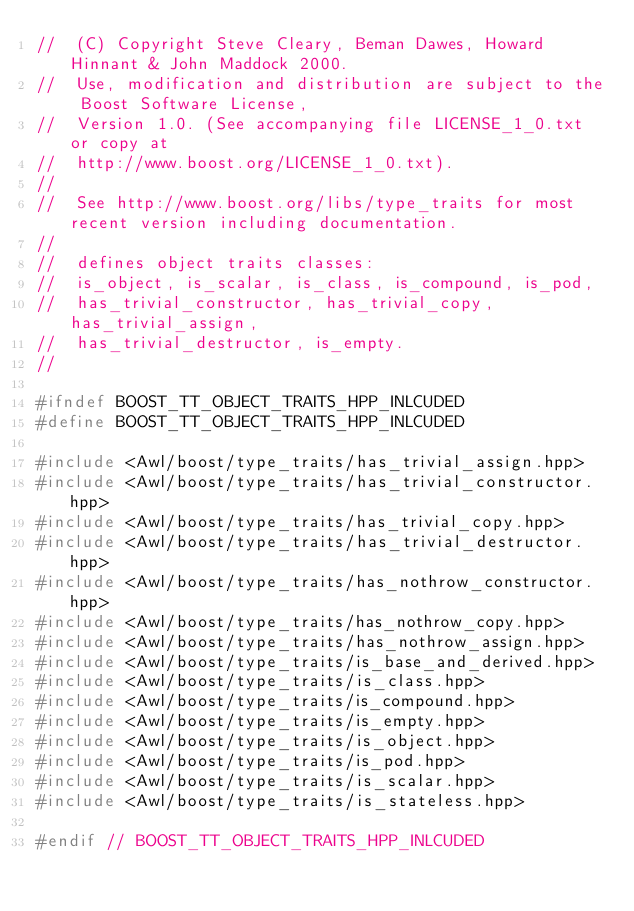Convert code to text. <code><loc_0><loc_0><loc_500><loc_500><_C++_>//  (C) Copyright Steve Cleary, Beman Dawes, Howard Hinnant & John Maddock 2000.
//  Use, modification and distribution are subject to the Boost Software License,
//  Version 1.0. (See accompanying file LICENSE_1_0.txt or copy at
//  http://www.boost.org/LICENSE_1_0.txt).
//
//  See http://www.boost.org/libs/type_traits for most recent version including documentation.
//
//  defines object traits classes:
//  is_object, is_scalar, is_class, is_compound, is_pod, 
//  has_trivial_constructor, has_trivial_copy, has_trivial_assign, 
//  has_trivial_destructor, is_empty.
//

#ifndef BOOST_TT_OBJECT_TRAITS_HPP_INLCUDED
#define BOOST_TT_OBJECT_TRAITS_HPP_INLCUDED

#include <Awl/boost/type_traits/has_trivial_assign.hpp>
#include <Awl/boost/type_traits/has_trivial_constructor.hpp>
#include <Awl/boost/type_traits/has_trivial_copy.hpp>
#include <Awl/boost/type_traits/has_trivial_destructor.hpp>
#include <Awl/boost/type_traits/has_nothrow_constructor.hpp>
#include <Awl/boost/type_traits/has_nothrow_copy.hpp>
#include <Awl/boost/type_traits/has_nothrow_assign.hpp>
#include <Awl/boost/type_traits/is_base_and_derived.hpp>
#include <Awl/boost/type_traits/is_class.hpp>
#include <Awl/boost/type_traits/is_compound.hpp>
#include <Awl/boost/type_traits/is_empty.hpp>
#include <Awl/boost/type_traits/is_object.hpp>
#include <Awl/boost/type_traits/is_pod.hpp>
#include <Awl/boost/type_traits/is_scalar.hpp>
#include <Awl/boost/type_traits/is_stateless.hpp>

#endif // BOOST_TT_OBJECT_TRAITS_HPP_INLCUDED
</code> 